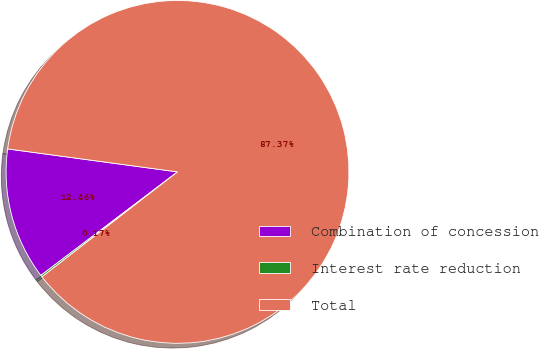<chart> <loc_0><loc_0><loc_500><loc_500><pie_chart><fcel>Combination of concession<fcel>Interest rate reduction<fcel>Total<nl><fcel>12.46%<fcel>0.17%<fcel>87.37%<nl></chart> 